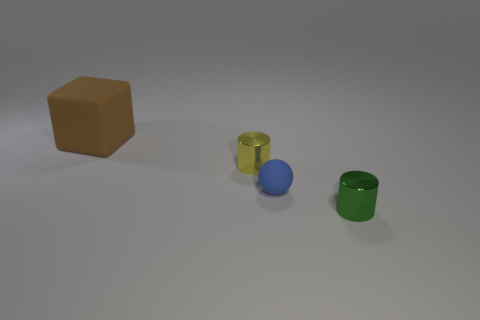Add 4 brown matte blocks. How many objects exist? 8 Subtract all cubes. How many objects are left? 3 Subtract 1 blue balls. How many objects are left? 3 Subtract all red cylinders. Subtract all yellow objects. How many objects are left? 3 Add 1 tiny metallic things. How many tiny metallic things are left? 3 Add 1 small cyan balls. How many small cyan balls exist? 1 